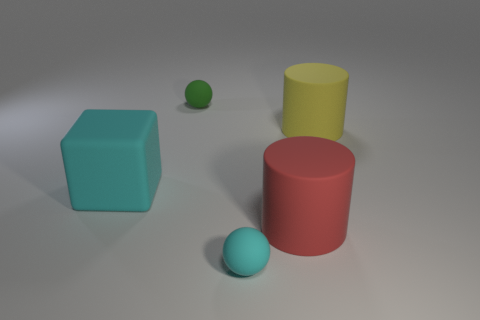Are there any other yellow objects that have the same shape as the big yellow thing? No, there are no other objects in the image that share the same cylindrical shape and yellow color as the larger yellow cylinder. 